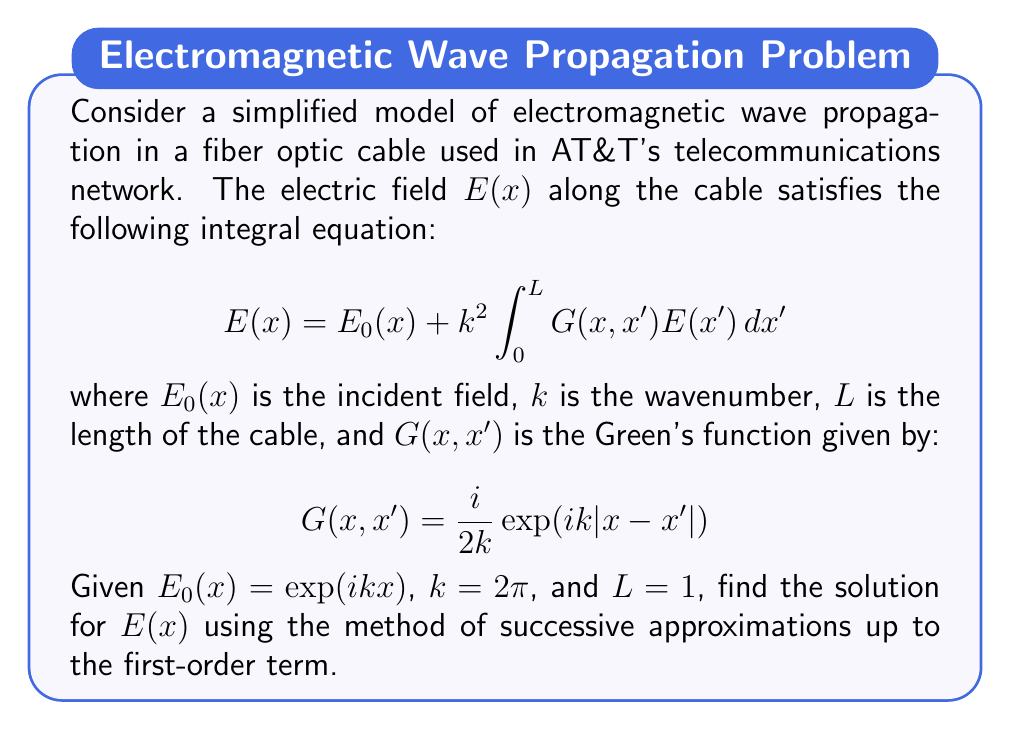Could you help me with this problem? To solve this problem, we'll use the method of successive approximations:

1) Start with the zeroth-order approximation:
   $$E_0(x) = \exp(ikx)$$

2) Substitute this into the integral equation to get the first-order approximation:

   $$E_1(x) = E_0(x) + k^2 \int_0^L G(x,x')E_0(x')dx'$$

3) Expand this equation:

   $$E_1(x) = \exp(ikx) + (2\pi)^2 \int_0^1 \frac{i}{4\pi}\exp(2\pi i|x-x'|)\exp(2\pi ix')dx'$$

4) Simplify the constant terms:

   $$E_1(x) = \exp(2\pi ix) + i\pi \int_0^1 \exp(2\pi i|x-x'|)\exp(2\pi ix')dx'$$

5) The integral can be split into two parts:

   $$E_1(x) = \exp(2\pi ix) + i\pi \left[\int_0^x \exp(2\pi i(x-x'))\exp(2\pi ix')dx' + \int_x^1 \exp(2\pi i(x'-x))\exp(2\pi ix')dx'\right]$$

6) Simplify the exponents:

   $$E_1(x) = \exp(2\pi ix) + i\pi \left[\int_0^x \exp(2\pi ix)dx' + \int_x^1 \exp(2\pi ix')dx'\right]$$

7) Evaluate the integrals:

   $$E_1(x) = \exp(2\pi ix) + i\pi \left[x\exp(2\pi ix) + \frac{1}{2\pi i}(\exp(2\pi i) - \exp(2\pi ix))\right]$$

8) Simplify:

   $$E_1(x) = \exp(2\pi ix)(1 + i\pi x) + \frac{1}{2}(\exp(2\pi i) - \exp(2\pi ix))$$

This is the first-order approximation for $E(x)$.
Answer: $E(x) \approx \exp(2\pi ix)(1 + i\pi x) + \frac{1}{2}(\exp(2\pi i) - \exp(2\pi ix))$ 